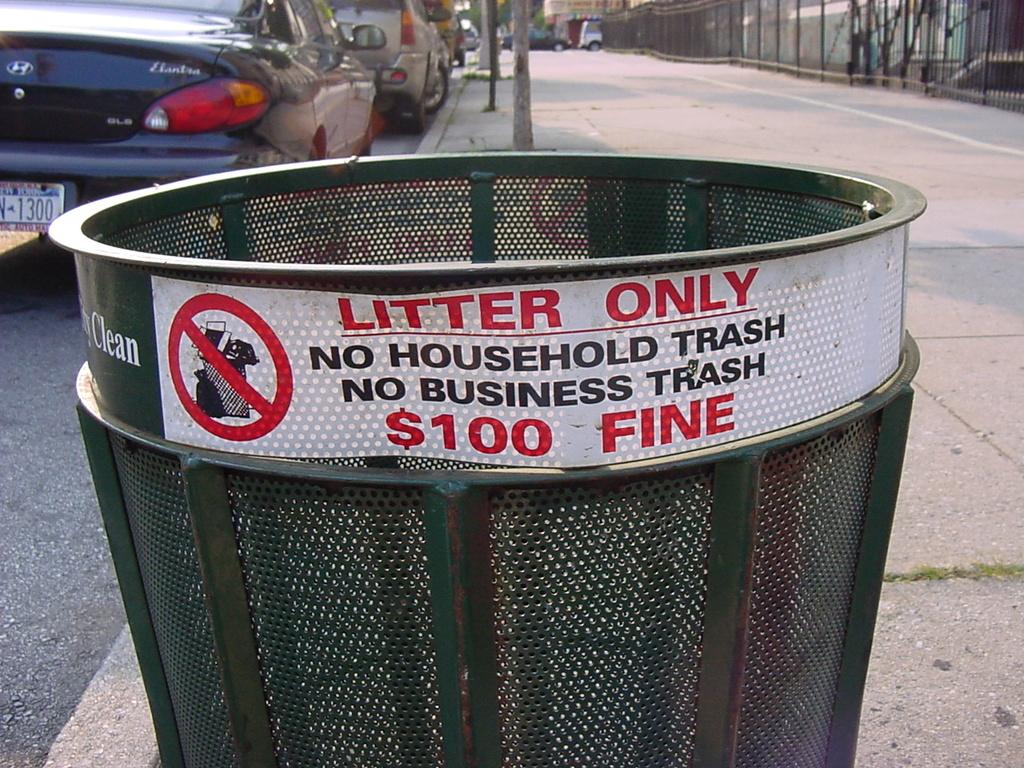Provide a one-sentence caption for the provided image. you will be fined100 dollars for putting household trash in this can. 